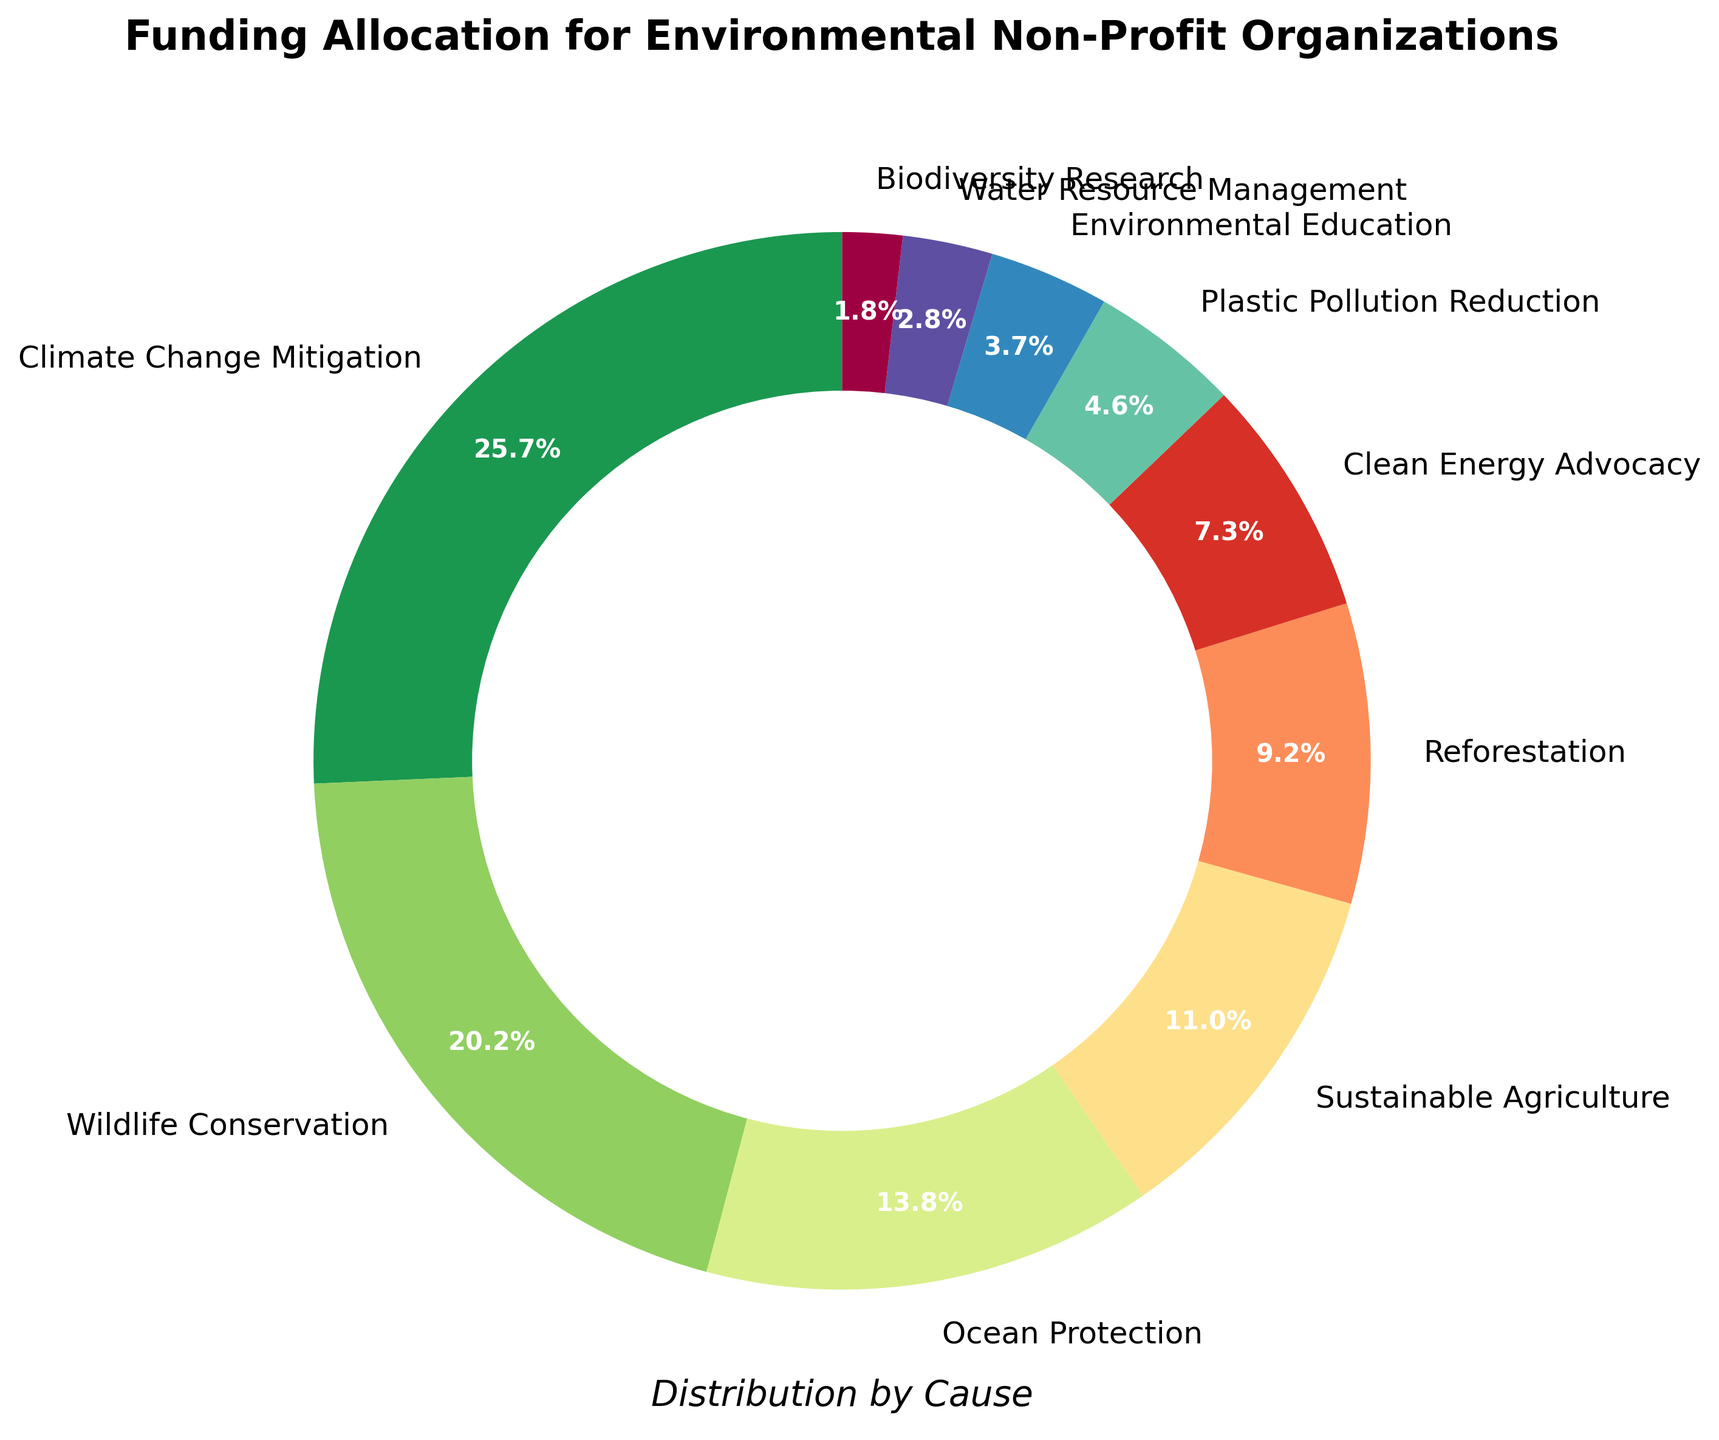What percentage of the funding is allocated to Ocean Protection and Sustainable Agriculture combined? First, find the percentage for Ocean Protection, which is 15%. Then find the percentage for Sustainable Agriculture, which is 12%. Add these percentages together: 15% + 12% = 27%
Answer: 27% Which cause receives more funding, Reforestation or Clean Energy Advocacy? The percentage for Reforestation is 10%, and the percentage for Clean Energy Advocacy is 8%. Compare these two values: 10% is greater than 8%
Answer: Reforestation What is the difference in funding allocation between Wildlife Conservation and Plastic Pollution Reduction? Find the percentage for Wildlife Conservation, which is 22%, and the percentage for Plastic Pollution Reduction, which is 5%. Subtract the smaller percentage from the larger one: 22% - 5% = 17%
Answer: 17% Which causes have funding allocations of less than 5%? Identify causes with percentages lower than 5%. The percentages are: Plastic Pollution Reduction (5%), Environmental Education (4%), Water Resource Management (3%), Biodiversity Research (2%). Only Environmental Education, Water Resource Management, and Biodiversity Research are under 5%
Answer: Environmental Education, Water Resource Management, Biodiversity Research Is the funding for Climate Change Mitigation more than double the funding for Clean Energy Advocacy? The percentage for Climate Change Mitigation is 28%, and the percentage for Clean Energy Advocacy is 8%. Double the percentage for Clean Energy Advocacy: 8% * 2 = 16%. Since 28% is greater than 16%, the funding for Climate Change Mitigation is more than double
Answer: Yes What is the average percentage for the top three funded causes? The top three causes are: Climate Change Mitigation (28%), Wildlife Conservation (22%), Ocean Protection (15%). Sum these percentages: 28% + 22% + 15% = 65%. Divide by 3 to find the average: 65% / 3 ≈ 21.67%
Answer: 21.67% Which cause has the lowest funding allocation? Look for the smallest percentage in the dataset. Biodiversity Research has the lowest with 2%
Answer: Biodiversity Research How much greater is the funding for Climate Change Mitigation compared to Sustainable Agriculture? The percentage for Climate Change Mitigation is 28%, and for Sustainable Agriculture, it is 12%. Subtract the smaller percentage from the larger one: 28% - 12% = 16%
Answer: 16% What is the total percentage allocation for causes related to water (Ocean Protection and Water Resource Management)? Find the percentage for Ocean Protection, which is 15%, and for Water Resource Management, which is 3%. Sum these percentages: 15% + 3% = 18%
Answer: 18% 